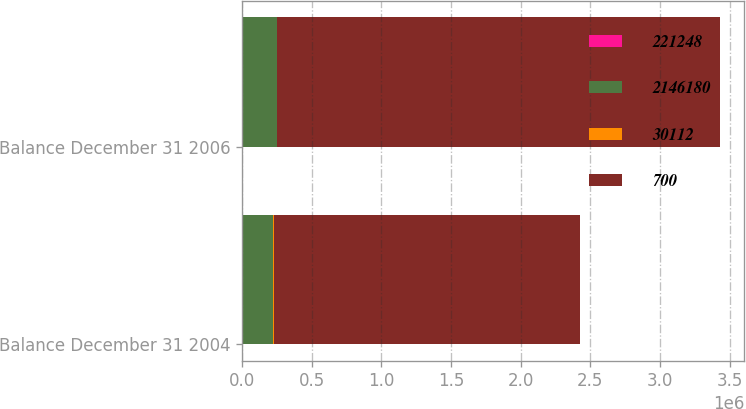Convert chart to OTSL. <chart><loc_0><loc_0><loc_500><loc_500><stacked_bar_chart><ecel><fcel>Balance December 31 2004<fcel>Balance December 31 2006<nl><fcel>221248<fcel>700<fcel>700<nl><fcel>2.14618e+06<fcel>224854<fcel>250870<nl><fcel>30112<fcel>2248<fcel>2509<nl><fcel>700<fcel>2.19942e+06<fcel>3.17802e+06<nl></chart> 